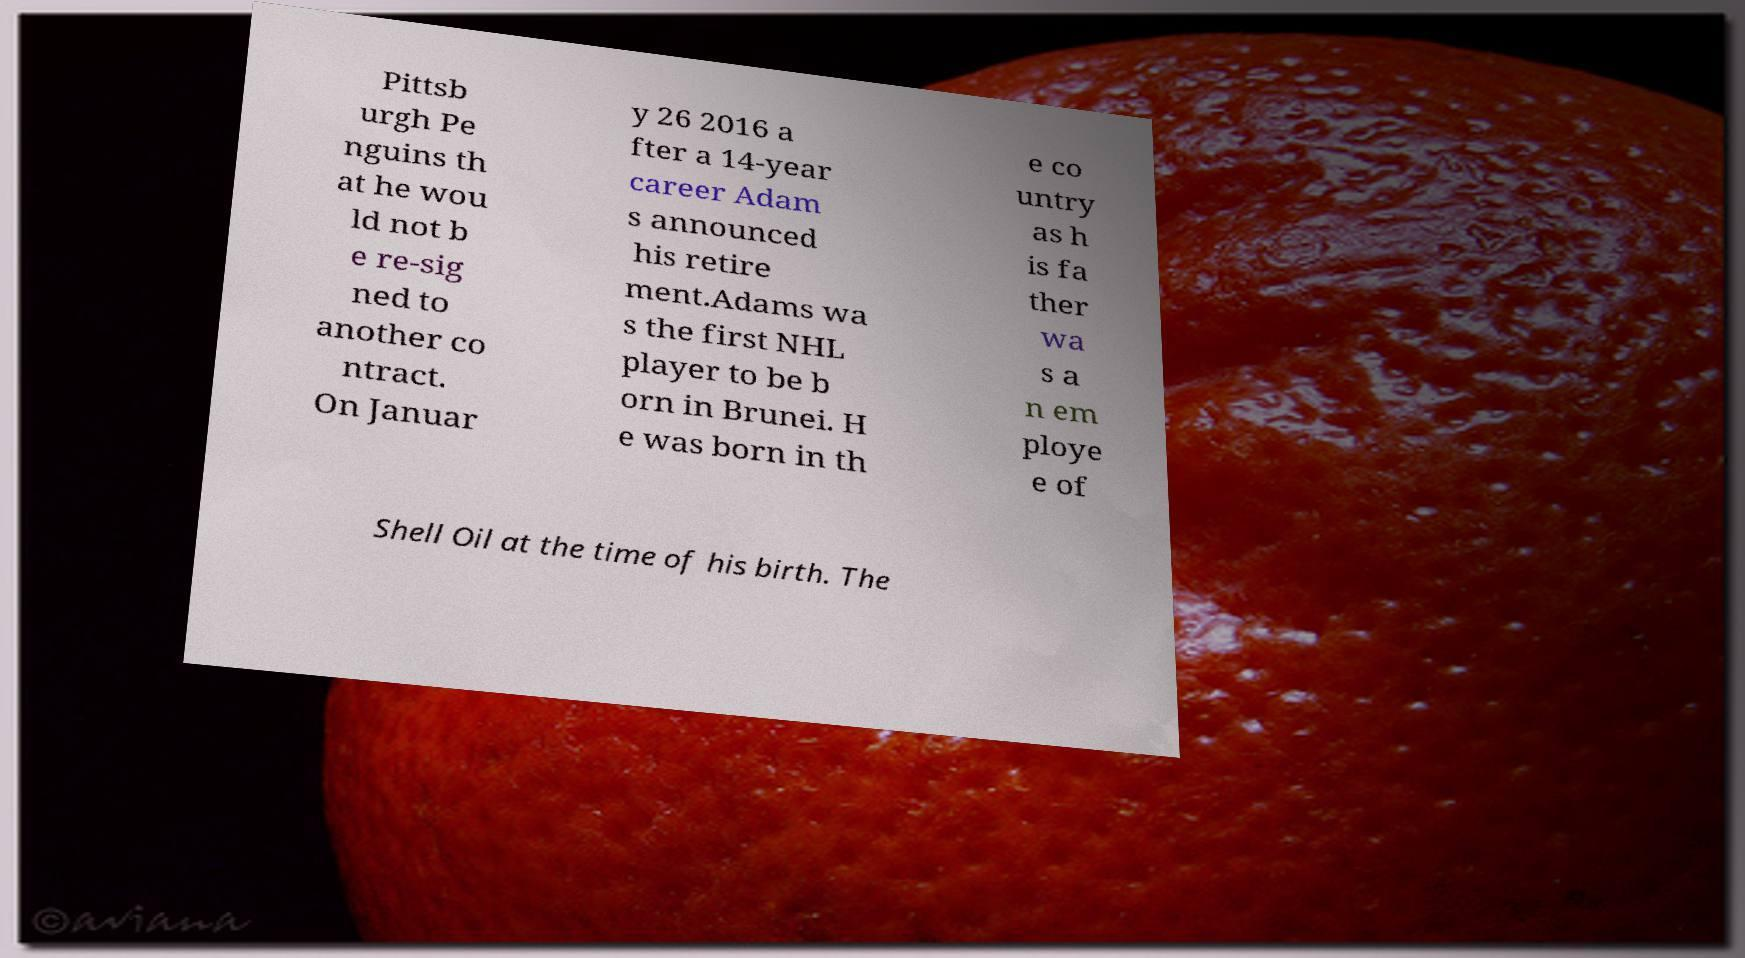Could you assist in decoding the text presented in this image and type it out clearly? Pittsb urgh Pe nguins th at he wou ld not b e re-sig ned to another co ntract. On Januar y 26 2016 a fter a 14-year career Adam s announced his retire ment.Adams wa s the first NHL player to be b orn in Brunei. H e was born in th e co untry as h is fa ther wa s a n em ploye e of Shell Oil at the time of his birth. The 